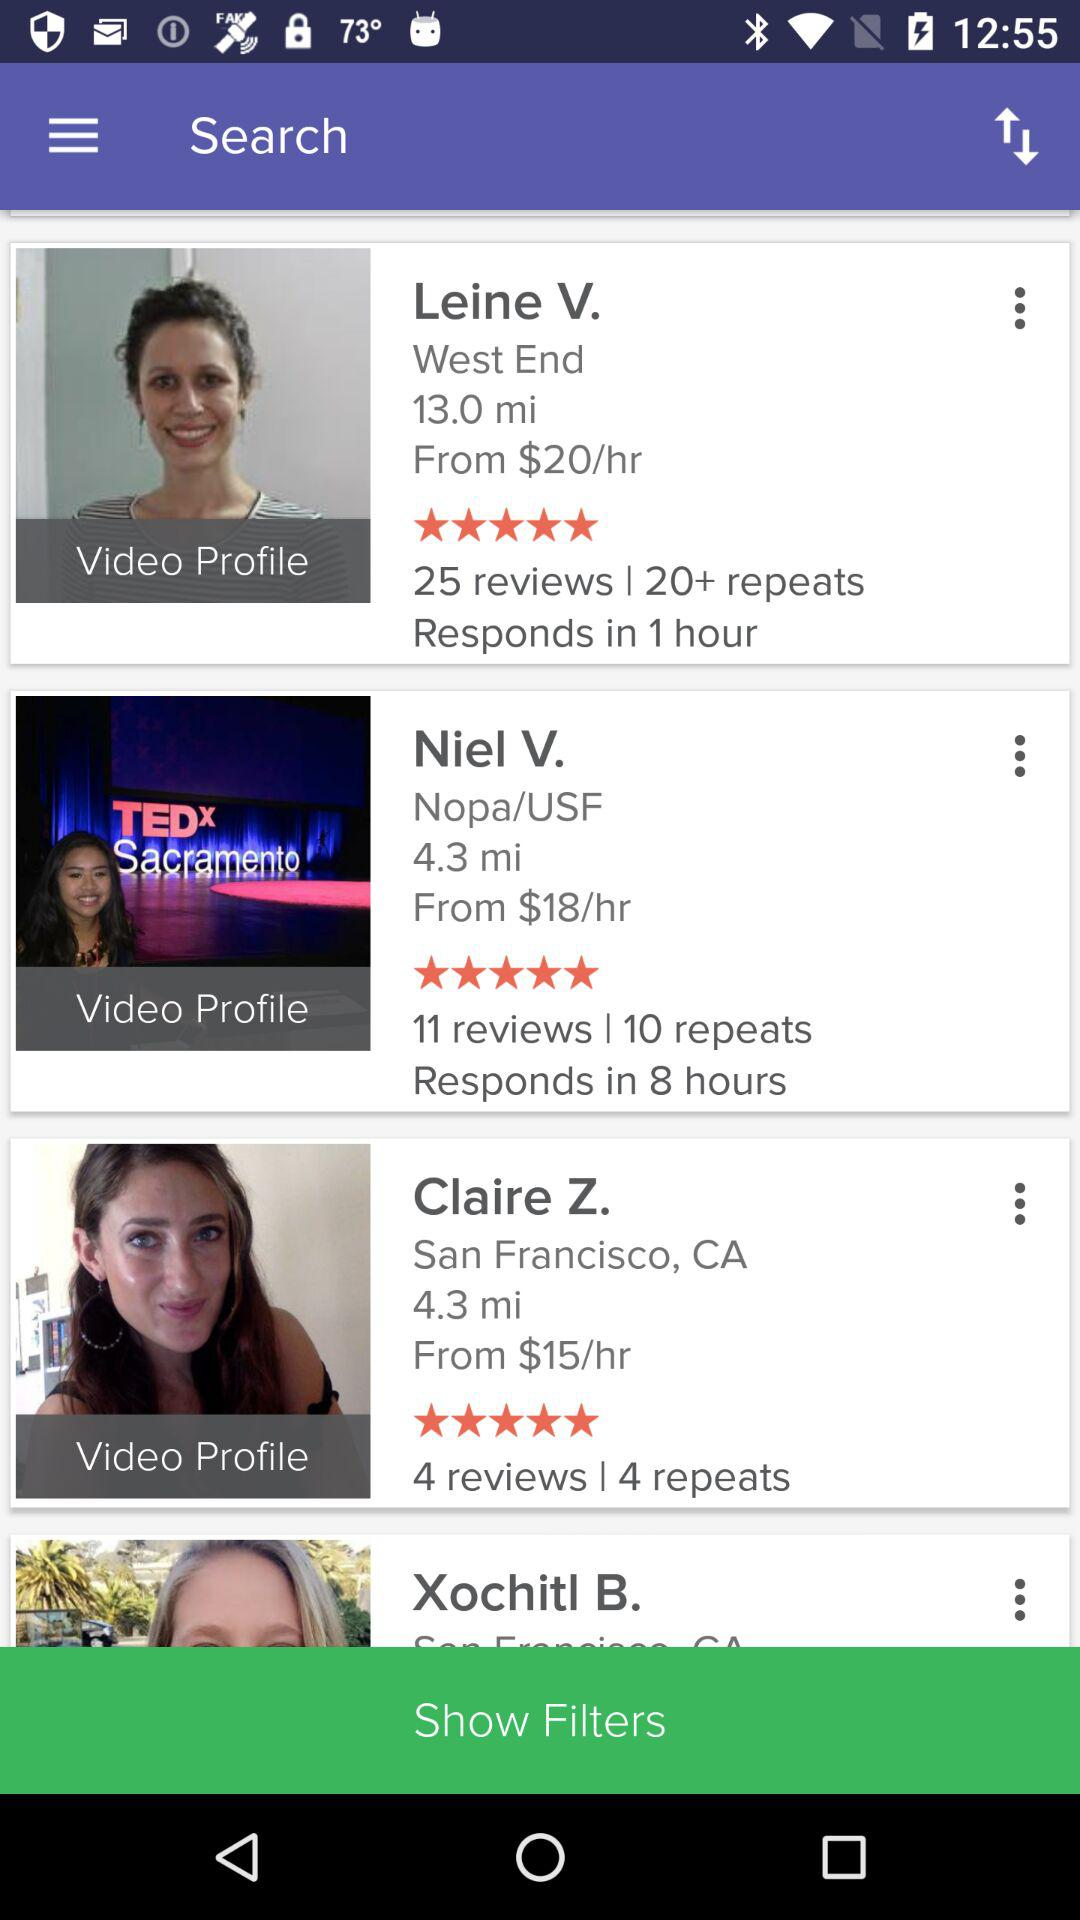Which profile has 11 reviews? The profile that has 11 reviews is of Niel V. 